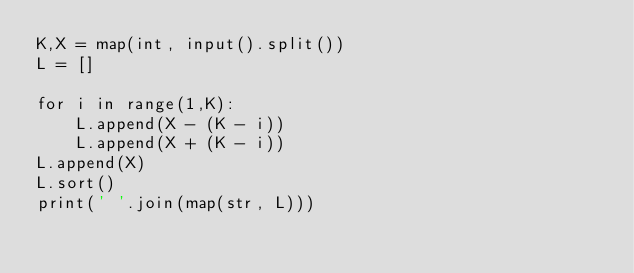<code> <loc_0><loc_0><loc_500><loc_500><_Python_>K,X = map(int, input().split())
L = []

for i in range(1,K):
    L.append(X - (K - i))
    L.append(X + (K - i))
L.append(X)
L.sort()
print(' '.join(map(str, L)))</code> 